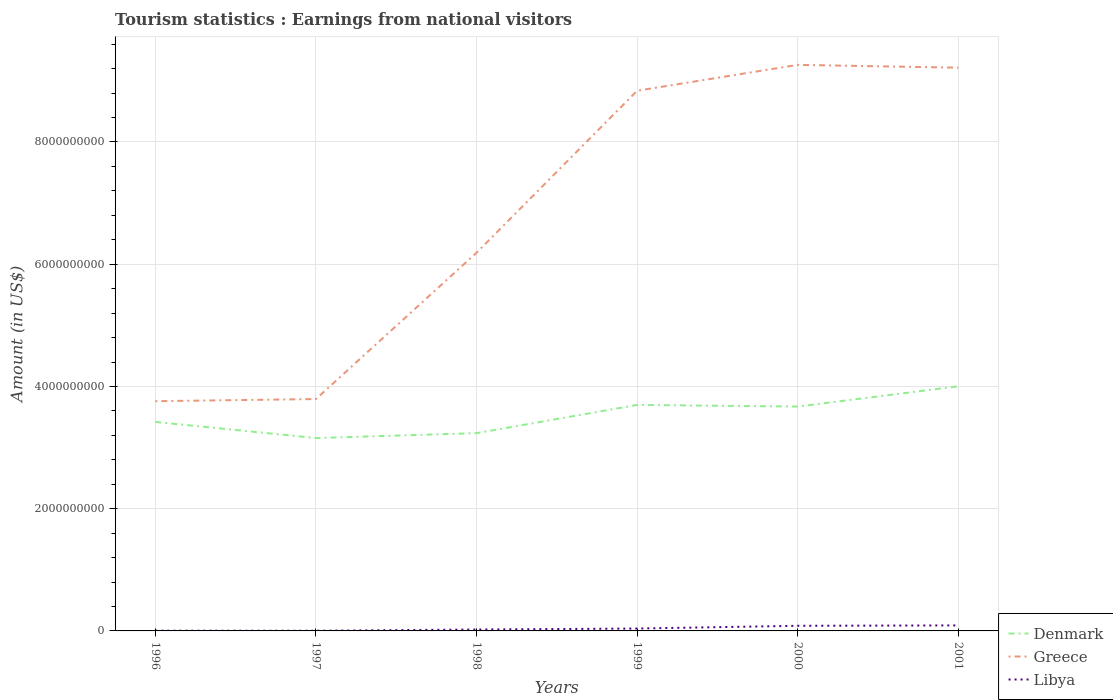What is the total earnings from national visitors in Libya in the graph?
Provide a short and direct response. -6.10e+07. What is the difference between the highest and the second highest earnings from national visitors in Greece?
Give a very brief answer. 5.50e+09. How many years are there in the graph?
Keep it short and to the point. 6. Does the graph contain any zero values?
Offer a very short reply. No. Does the graph contain grids?
Provide a succinct answer. Yes. Where does the legend appear in the graph?
Offer a very short reply. Bottom right. How many legend labels are there?
Give a very brief answer. 3. What is the title of the graph?
Ensure brevity in your answer.  Tourism statistics : Earnings from national visitors. What is the label or title of the X-axis?
Your response must be concise. Years. What is the label or title of the Y-axis?
Your response must be concise. Amount (in US$). What is the Amount (in US$) of Denmark in 1996?
Ensure brevity in your answer.  3.42e+09. What is the Amount (in US$) in Greece in 1996?
Offer a very short reply. 3.76e+09. What is the Amount (in US$) in Libya in 1996?
Ensure brevity in your answer.  4.00e+06. What is the Amount (in US$) of Denmark in 1997?
Give a very brief answer. 3.16e+09. What is the Amount (in US$) of Greece in 1997?
Provide a short and direct response. 3.79e+09. What is the Amount (in US$) of Libya in 1997?
Offer a very short reply. 3.00e+06. What is the Amount (in US$) in Denmark in 1998?
Provide a succinct answer. 3.24e+09. What is the Amount (in US$) in Greece in 1998?
Offer a very short reply. 6.19e+09. What is the Amount (in US$) of Libya in 1998?
Offer a terse response. 2.30e+07. What is the Amount (in US$) of Denmark in 1999?
Provide a succinct answer. 3.70e+09. What is the Amount (in US$) of Greece in 1999?
Make the answer very short. 8.84e+09. What is the Amount (in US$) of Libya in 1999?
Your answer should be very brief. 3.90e+07. What is the Amount (in US$) in Denmark in 2000?
Your answer should be very brief. 3.67e+09. What is the Amount (in US$) in Greece in 2000?
Offer a very short reply. 9.26e+09. What is the Amount (in US$) in Libya in 2000?
Offer a terse response. 8.40e+07. What is the Amount (in US$) of Denmark in 2001?
Make the answer very short. 4.00e+09. What is the Amount (in US$) in Greece in 2001?
Your answer should be compact. 9.22e+09. What is the Amount (in US$) of Libya in 2001?
Provide a succinct answer. 9.00e+07. Across all years, what is the maximum Amount (in US$) in Denmark?
Make the answer very short. 4.00e+09. Across all years, what is the maximum Amount (in US$) in Greece?
Offer a very short reply. 9.26e+09. Across all years, what is the maximum Amount (in US$) in Libya?
Offer a terse response. 9.00e+07. Across all years, what is the minimum Amount (in US$) in Denmark?
Provide a short and direct response. 3.16e+09. Across all years, what is the minimum Amount (in US$) of Greece?
Provide a succinct answer. 3.76e+09. What is the total Amount (in US$) in Denmark in the graph?
Keep it short and to the point. 2.12e+1. What is the total Amount (in US$) in Greece in the graph?
Keep it short and to the point. 4.11e+1. What is the total Amount (in US$) in Libya in the graph?
Your answer should be very brief. 2.43e+08. What is the difference between the Amount (in US$) in Denmark in 1996 and that in 1997?
Ensure brevity in your answer.  2.64e+08. What is the difference between the Amount (in US$) of Greece in 1996 and that in 1997?
Give a very brief answer. -3.50e+07. What is the difference between the Amount (in US$) of Libya in 1996 and that in 1997?
Offer a very short reply. 1.00e+06. What is the difference between the Amount (in US$) in Denmark in 1996 and that in 1998?
Offer a very short reply. 1.84e+08. What is the difference between the Amount (in US$) in Greece in 1996 and that in 1998?
Provide a short and direct response. -2.43e+09. What is the difference between the Amount (in US$) in Libya in 1996 and that in 1998?
Give a very brief answer. -1.90e+07. What is the difference between the Amount (in US$) in Denmark in 1996 and that in 1999?
Offer a terse response. -2.78e+08. What is the difference between the Amount (in US$) of Greece in 1996 and that in 1999?
Offer a very short reply. -5.08e+09. What is the difference between the Amount (in US$) of Libya in 1996 and that in 1999?
Your answer should be compact. -3.50e+07. What is the difference between the Amount (in US$) in Denmark in 1996 and that in 2000?
Offer a very short reply. -2.51e+08. What is the difference between the Amount (in US$) of Greece in 1996 and that in 2000?
Ensure brevity in your answer.  -5.50e+09. What is the difference between the Amount (in US$) of Libya in 1996 and that in 2000?
Provide a short and direct response. -8.00e+07. What is the difference between the Amount (in US$) of Denmark in 1996 and that in 2001?
Provide a short and direct response. -5.83e+08. What is the difference between the Amount (in US$) in Greece in 1996 and that in 2001?
Your response must be concise. -5.46e+09. What is the difference between the Amount (in US$) in Libya in 1996 and that in 2001?
Your answer should be compact. -8.60e+07. What is the difference between the Amount (in US$) of Denmark in 1997 and that in 1998?
Give a very brief answer. -8.00e+07. What is the difference between the Amount (in US$) of Greece in 1997 and that in 1998?
Your answer should be very brief. -2.39e+09. What is the difference between the Amount (in US$) in Libya in 1997 and that in 1998?
Your response must be concise. -2.00e+07. What is the difference between the Amount (in US$) of Denmark in 1997 and that in 1999?
Provide a short and direct response. -5.42e+08. What is the difference between the Amount (in US$) of Greece in 1997 and that in 1999?
Your response must be concise. -5.04e+09. What is the difference between the Amount (in US$) in Libya in 1997 and that in 1999?
Keep it short and to the point. -3.60e+07. What is the difference between the Amount (in US$) of Denmark in 1997 and that in 2000?
Ensure brevity in your answer.  -5.15e+08. What is the difference between the Amount (in US$) in Greece in 1997 and that in 2000?
Provide a short and direct response. -5.47e+09. What is the difference between the Amount (in US$) in Libya in 1997 and that in 2000?
Your answer should be compact. -8.10e+07. What is the difference between the Amount (in US$) of Denmark in 1997 and that in 2001?
Your response must be concise. -8.47e+08. What is the difference between the Amount (in US$) of Greece in 1997 and that in 2001?
Your answer should be compact. -5.42e+09. What is the difference between the Amount (in US$) of Libya in 1997 and that in 2001?
Offer a very short reply. -8.70e+07. What is the difference between the Amount (in US$) of Denmark in 1998 and that in 1999?
Offer a terse response. -4.62e+08. What is the difference between the Amount (in US$) in Greece in 1998 and that in 1999?
Give a very brief answer. -2.65e+09. What is the difference between the Amount (in US$) in Libya in 1998 and that in 1999?
Offer a terse response. -1.60e+07. What is the difference between the Amount (in US$) of Denmark in 1998 and that in 2000?
Give a very brief answer. -4.35e+08. What is the difference between the Amount (in US$) in Greece in 1998 and that in 2000?
Keep it short and to the point. -3.07e+09. What is the difference between the Amount (in US$) of Libya in 1998 and that in 2000?
Ensure brevity in your answer.  -6.10e+07. What is the difference between the Amount (in US$) of Denmark in 1998 and that in 2001?
Your answer should be very brief. -7.67e+08. What is the difference between the Amount (in US$) in Greece in 1998 and that in 2001?
Keep it short and to the point. -3.03e+09. What is the difference between the Amount (in US$) in Libya in 1998 and that in 2001?
Provide a succinct answer. -6.70e+07. What is the difference between the Amount (in US$) in Denmark in 1999 and that in 2000?
Provide a succinct answer. 2.70e+07. What is the difference between the Amount (in US$) in Greece in 1999 and that in 2000?
Ensure brevity in your answer.  -4.23e+08. What is the difference between the Amount (in US$) in Libya in 1999 and that in 2000?
Ensure brevity in your answer.  -4.50e+07. What is the difference between the Amount (in US$) in Denmark in 1999 and that in 2001?
Provide a short and direct response. -3.05e+08. What is the difference between the Amount (in US$) in Greece in 1999 and that in 2001?
Provide a succinct answer. -3.77e+08. What is the difference between the Amount (in US$) in Libya in 1999 and that in 2001?
Make the answer very short. -5.10e+07. What is the difference between the Amount (in US$) in Denmark in 2000 and that in 2001?
Your response must be concise. -3.32e+08. What is the difference between the Amount (in US$) in Greece in 2000 and that in 2001?
Your answer should be very brief. 4.60e+07. What is the difference between the Amount (in US$) of Libya in 2000 and that in 2001?
Provide a short and direct response. -6.00e+06. What is the difference between the Amount (in US$) of Denmark in 1996 and the Amount (in US$) of Greece in 1997?
Give a very brief answer. -3.74e+08. What is the difference between the Amount (in US$) of Denmark in 1996 and the Amount (in US$) of Libya in 1997?
Offer a very short reply. 3.42e+09. What is the difference between the Amount (in US$) of Greece in 1996 and the Amount (in US$) of Libya in 1997?
Give a very brief answer. 3.76e+09. What is the difference between the Amount (in US$) in Denmark in 1996 and the Amount (in US$) in Greece in 1998?
Ensure brevity in your answer.  -2.77e+09. What is the difference between the Amount (in US$) in Denmark in 1996 and the Amount (in US$) in Libya in 1998?
Ensure brevity in your answer.  3.40e+09. What is the difference between the Amount (in US$) of Greece in 1996 and the Amount (in US$) of Libya in 1998?
Offer a very short reply. 3.74e+09. What is the difference between the Amount (in US$) of Denmark in 1996 and the Amount (in US$) of Greece in 1999?
Ensure brevity in your answer.  -5.42e+09. What is the difference between the Amount (in US$) of Denmark in 1996 and the Amount (in US$) of Libya in 1999?
Keep it short and to the point. 3.38e+09. What is the difference between the Amount (in US$) of Greece in 1996 and the Amount (in US$) of Libya in 1999?
Give a very brief answer. 3.72e+09. What is the difference between the Amount (in US$) in Denmark in 1996 and the Amount (in US$) in Greece in 2000?
Ensure brevity in your answer.  -5.84e+09. What is the difference between the Amount (in US$) of Denmark in 1996 and the Amount (in US$) of Libya in 2000?
Make the answer very short. 3.34e+09. What is the difference between the Amount (in US$) in Greece in 1996 and the Amount (in US$) in Libya in 2000?
Offer a very short reply. 3.68e+09. What is the difference between the Amount (in US$) in Denmark in 1996 and the Amount (in US$) in Greece in 2001?
Provide a succinct answer. -5.80e+09. What is the difference between the Amount (in US$) in Denmark in 1996 and the Amount (in US$) in Libya in 2001?
Your answer should be compact. 3.33e+09. What is the difference between the Amount (in US$) of Greece in 1996 and the Amount (in US$) of Libya in 2001?
Your answer should be very brief. 3.67e+09. What is the difference between the Amount (in US$) of Denmark in 1997 and the Amount (in US$) of Greece in 1998?
Provide a succinct answer. -3.03e+09. What is the difference between the Amount (in US$) in Denmark in 1997 and the Amount (in US$) in Libya in 1998?
Make the answer very short. 3.13e+09. What is the difference between the Amount (in US$) of Greece in 1997 and the Amount (in US$) of Libya in 1998?
Your response must be concise. 3.77e+09. What is the difference between the Amount (in US$) in Denmark in 1997 and the Amount (in US$) in Greece in 1999?
Your response must be concise. -5.68e+09. What is the difference between the Amount (in US$) of Denmark in 1997 and the Amount (in US$) of Libya in 1999?
Offer a very short reply. 3.12e+09. What is the difference between the Amount (in US$) in Greece in 1997 and the Amount (in US$) in Libya in 1999?
Give a very brief answer. 3.76e+09. What is the difference between the Amount (in US$) in Denmark in 1997 and the Amount (in US$) in Greece in 2000?
Ensure brevity in your answer.  -6.11e+09. What is the difference between the Amount (in US$) of Denmark in 1997 and the Amount (in US$) of Libya in 2000?
Keep it short and to the point. 3.07e+09. What is the difference between the Amount (in US$) in Greece in 1997 and the Amount (in US$) in Libya in 2000?
Your response must be concise. 3.71e+09. What is the difference between the Amount (in US$) in Denmark in 1997 and the Amount (in US$) in Greece in 2001?
Ensure brevity in your answer.  -6.06e+09. What is the difference between the Amount (in US$) of Denmark in 1997 and the Amount (in US$) of Libya in 2001?
Ensure brevity in your answer.  3.07e+09. What is the difference between the Amount (in US$) in Greece in 1997 and the Amount (in US$) in Libya in 2001?
Make the answer very short. 3.70e+09. What is the difference between the Amount (in US$) in Denmark in 1998 and the Amount (in US$) in Greece in 1999?
Give a very brief answer. -5.60e+09. What is the difference between the Amount (in US$) of Denmark in 1998 and the Amount (in US$) of Libya in 1999?
Your answer should be compact. 3.20e+09. What is the difference between the Amount (in US$) of Greece in 1998 and the Amount (in US$) of Libya in 1999?
Ensure brevity in your answer.  6.15e+09. What is the difference between the Amount (in US$) of Denmark in 1998 and the Amount (in US$) of Greece in 2000?
Make the answer very short. -6.03e+09. What is the difference between the Amount (in US$) of Denmark in 1998 and the Amount (in US$) of Libya in 2000?
Your answer should be very brief. 3.15e+09. What is the difference between the Amount (in US$) in Greece in 1998 and the Amount (in US$) in Libya in 2000?
Give a very brief answer. 6.10e+09. What is the difference between the Amount (in US$) in Denmark in 1998 and the Amount (in US$) in Greece in 2001?
Ensure brevity in your answer.  -5.98e+09. What is the difference between the Amount (in US$) in Denmark in 1998 and the Amount (in US$) in Libya in 2001?
Your answer should be compact. 3.15e+09. What is the difference between the Amount (in US$) of Greece in 1998 and the Amount (in US$) of Libya in 2001?
Offer a very short reply. 6.10e+09. What is the difference between the Amount (in US$) in Denmark in 1999 and the Amount (in US$) in Greece in 2000?
Provide a short and direct response. -5.56e+09. What is the difference between the Amount (in US$) of Denmark in 1999 and the Amount (in US$) of Libya in 2000?
Offer a terse response. 3.61e+09. What is the difference between the Amount (in US$) of Greece in 1999 and the Amount (in US$) of Libya in 2000?
Give a very brief answer. 8.76e+09. What is the difference between the Amount (in US$) in Denmark in 1999 and the Amount (in US$) in Greece in 2001?
Keep it short and to the point. -5.52e+09. What is the difference between the Amount (in US$) in Denmark in 1999 and the Amount (in US$) in Libya in 2001?
Ensure brevity in your answer.  3.61e+09. What is the difference between the Amount (in US$) in Greece in 1999 and the Amount (in US$) in Libya in 2001?
Your answer should be compact. 8.75e+09. What is the difference between the Amount (in US$) in Denmark in 2000 and the Amount (in US$) in Greece in 2001?
Ensure brevity in your answer.  -5.54e+09. What is the difference between the Amount (in US$) in Denmark in 2000 and the Amount (in US$) in Libya in 2001?
Provide a short and direct response. 3.58e+09. What is the difference between the Amount (in US$) of Greece in 2000 and the Amount (in US$) of Libya in 2001?
Your response must be concise. 9.17e+09. What is the average Amount (in US$) in Denmark per year?
Provide a succinct answer. 3.53e+09. What is the average Amount (in US$) in Greece per year?
Keep it short and to the point. 6.84e+09. What is the average Amount (in US$) in Libya per year?
Make the answer very short. 4.05e+07. In the year 1996, what is the difference between the Amount (in US$) of Denmark and Amount (in US$) of Greece?
Provide a succinct answer. -3.39e+08. In the year 1996, what is the difference between the Amount (in US$) in Denmark and Amount (in US$) in Libya?
Offer a very short reply. 3.42e+09. In the year 1996, what is the difference between the Amount (in US$) in Greece and Amount (in US$) in Libya?
Offer a very short reply. 3.76e+09. In the year 1997, what is the difference between the Amount (in US$) of Denmark and Amount (in US$) of Greece?
Your answer should be compact. -6.38e+08. In the year 1997, what is the difference between the Amount (in US$) of Denmark and Amount (in US$) of Libya?
Offer a very short reply. 3.15e+09. In the year 1997, what is the difference between the Amount (in US$) of Greece and Amount (in US$) of Libya?
Your answer should be compact. 3.79e+09. In the year 1998, what is the difference between the Amount (in US$) in Denmark and Amount (in US$) in Greece?
Provide a succinct answer. -2.95e+09. In the year 1998, what is the difference between the Amount (in US$) in Denmark and Amount (in US$) in Libya?
Your answer should be compact. 3.21e+09. In the year 1998, what is the difference between the Amount (in US$) of Greece and Amount (in US$) of Libya?
Ensure brevity in your answer.  6.16e+09. In the year 1999, what is the difference between the Amount (in US$) in Denmark and Amount (in US$) in Greece?
Provide a short and direct response. -5.14e+09. In the year 1999, what is the difference between the Amount (in US$) of Denmark and Amount (in US$) of Libya?
Your answer should be very brief. 3.66e+09. In the year 1999, what is the difference between the Amount (in US$) in Greece and Amount (in US$) in Libya?
Your answer should be compact. 8.80e+09. In the year 2000, what is the difference between the Amount (in US$) of Denmark and Amount (in US$) of Greece?
Give a very brief answer. -5.59e+09. In the year 2000, what is the difference between the Amount (in US$) of Denmark and Amount (in US$) of Libya?
Your response must be concise. 3.59e+09. In the year 2000, what is the difference between the Amount (in US$) in Greece and Amount (in US$) in Libya?
Your answer should be compact. 9.18e+09. In the year 2001, what is the difference between the Amount (in US$) in Denmark and Amount (in US$) in Greece?
Your answer should be compact. -5.21e+09. In the year 2001, what is the difference between the Amount (in US$) in Denmark and Amount (in US$) in Libya?
Ensure brevity in your answer.  3.91e+09. In the year 2001, what is the difference between the Amount (in US$) of Greece and Amount (in US$) of Libya?
Make the answer very short. 9.13e+09. What is the ratio of the Amount (in US$) of Denmark in 1996 to that in 1997?
Give a very brief answer. 1.08. What is the ratio of the Amount (in US$) in Denmark in 1996 to that in 1998?
Provide a short and direct response. 1.06. What is the ratio of the Amount (in US$) in Greece in 1996 to that in 1998?
Offer a very short reply. 0.61. What is the ratio of the Amount (in US$) of Libya in 1996 to that in 1998?
Provide a short and direct response. 0.17. What is the ratio of the Amount (in US$) of Denmark in 1996 to that in 1999?
Provide a short and direct response. 0.92. What is the ratio of the Amount (in US$) in Greece in 1996 to that in 1999?
Your response must be concise. 0.43. What is the ratio of the Amount (in US$) in Libya in 1996 to that in 1999?
Ensure brevity in your answer.  0.1. What is the ratio of the Amount (in US$) of Denmark in 1996 to that in 2000?
Provide a succinct answer. 0.93. What is the ratio of the Amount (in US$) in Greece in 1996 to that in 2000?
Keep it short and to the point. 0.41. What is the ratio of the Amount (in US$) of Libya in 1996 to that in 2000?
Give a very brief answer. 0.05. What is the ratio of the Amount (in US$) in Denmark in 1996 to that in 2001?
Your response must be concise. 0.85. What is the ratio of the Amount (in US$) of Greece in 1996 to that in 2001?
Your response must be concise. 0.41. What is the ratio of the Amount (in US$) of Libya in 1996 to that in 2001?
Your response must be concise. 0.04. What is the ratio of the Amount (in US$) in Denmark in 1997 to that in 1998?
Your response must be concise. 0.98. What is the ratio of the Amount (in US$) in Greece in 1997 to that in 1998?
Your response must be concise. 0.61. What is the ratio of the Amount (in US$) of Libya in 1997 to that in 1998?
Your response must be concise. 0.13. What is the ratio of the Amount (in US$) in Denmark in 1997 to that in 1999?
Your answer should be very brief. 0.85. What is the ratio of the Amount (in US$) in Greece in 1997 to that in 1999?
Give a very brief answer. 0.43. What is the ratio of the Amount (in US$) in Libya in 1997 to that in 1999?
Your response must be concise. 0.08. What is the ratio of the Amount (in US$) in Denmark in 1997 to that in 2000?
Provide a short and direct response. 0.86. What is the ratio of the Amount (in US$) in Greece in 1997 to that in 2000?
Offer a very short reply. 0.41. What is the ratio of the Amount (in US$) in Libya in 1997 to that in 2000?
Give a very brief answer. 0.04. What is the ratio of the Amount (in US$) of Denmark in 1997 to that in 2001?
Keep it short and to the point. 0.79. What is the ratio of the Amount (in US$) of Greece in 1997 to that in 2001?
Make the answer very short. 0.41. What is the ratio of the Amount (in US$) in Libya in 1997 to that in 2001?
Offer a terse response. 0.03. What is the ratio of the Amount (in US$) in Denmark in 1998 to that in 1999?
Your answer should be very brief. 0.88. What is the ratio of the Amount (in US$) of Greece in 1998 to that in 1999?
Your response must be concise. 0.7. What is the ratio of the Amount (in US$) in Libya in 1998 to that in 1999?
Keep it short and to the point. 0.59. What is the ratio of the Amount (in US$) in Denmark in 1998 to that in 2000?
Your response must be concise. 0.88. What is the ratio of the Amount (in US$) of Greece in 1998 to that in 2000?
Keep it short and to the point. 0.67. What is the ratio of the Amount (in US$) of Libya in 1998 to that in 2000?
Your answer should be compact. 0.27. What is the ratio of the Amount (in US$) in Denmark in 1998 to that in 2001?
Your response must be concise. 0.81. What is the ratio of the Amount (in US$) in Greece in 1998 to that in 2001?
Make the answer very short. 0.67. What is the ratio of the Amount (in US$) of Libya in 1998 to that in 2001?
Your response must be concise. 0.26. What is the ratio of the Amount (in US$) in Denmark in 1999 to that in 2000?
Make the answer very short. 1.01. What is the ratio of the Amount (in US$) of Greece in 1999 to that in 2000?
Make the answer very short. 0.95. What is the ratio of the Amount (in US$) of Libya in 1999 to that in 2000?
Make the answer very short. 0.46. What is the ratio of the Amount (in US$) of Denmark in 1999 to that in 2001?
Your response must be concise. 0.92. What is the ratio of the Amount (in US$) in Greece in 1999 to that in 2001?
Your answer should be compact. 0.96. What is the ratio of the Amount (in US$) of Libya in 1999 to that in 2001?
Ensure brevity in your answer.  0.43. What is the ratio of the Amount (in US$) of Denmark in 2000 to that in 2001?
Your answer should be compact. 0.92. What is the ratio of the Amount (in US$) in Greece in 2000 to that in 2001?
Offer a terse response. 1. What is the difference between the highest and the second highest Amount (in US$) of Denmark?
Your response must be concise. 3.05e+08. What is the difference between the highest and the second highest Amount (in US$) in Greece?
Offer a terse response. 4.60e+07. What is the difference between the highest and the lowest Amount (in US$) of Denmark?
Your answer should be very brief. 8.47e+08. What is the difference between the highest and the lowest Amount (in US$) of Greece?
Offer a very short reply. 5.50e+09. What is the difference between the highest and the lowest Amount (in US$) of Libya?
Your response must be concise. 8.70e+07. 